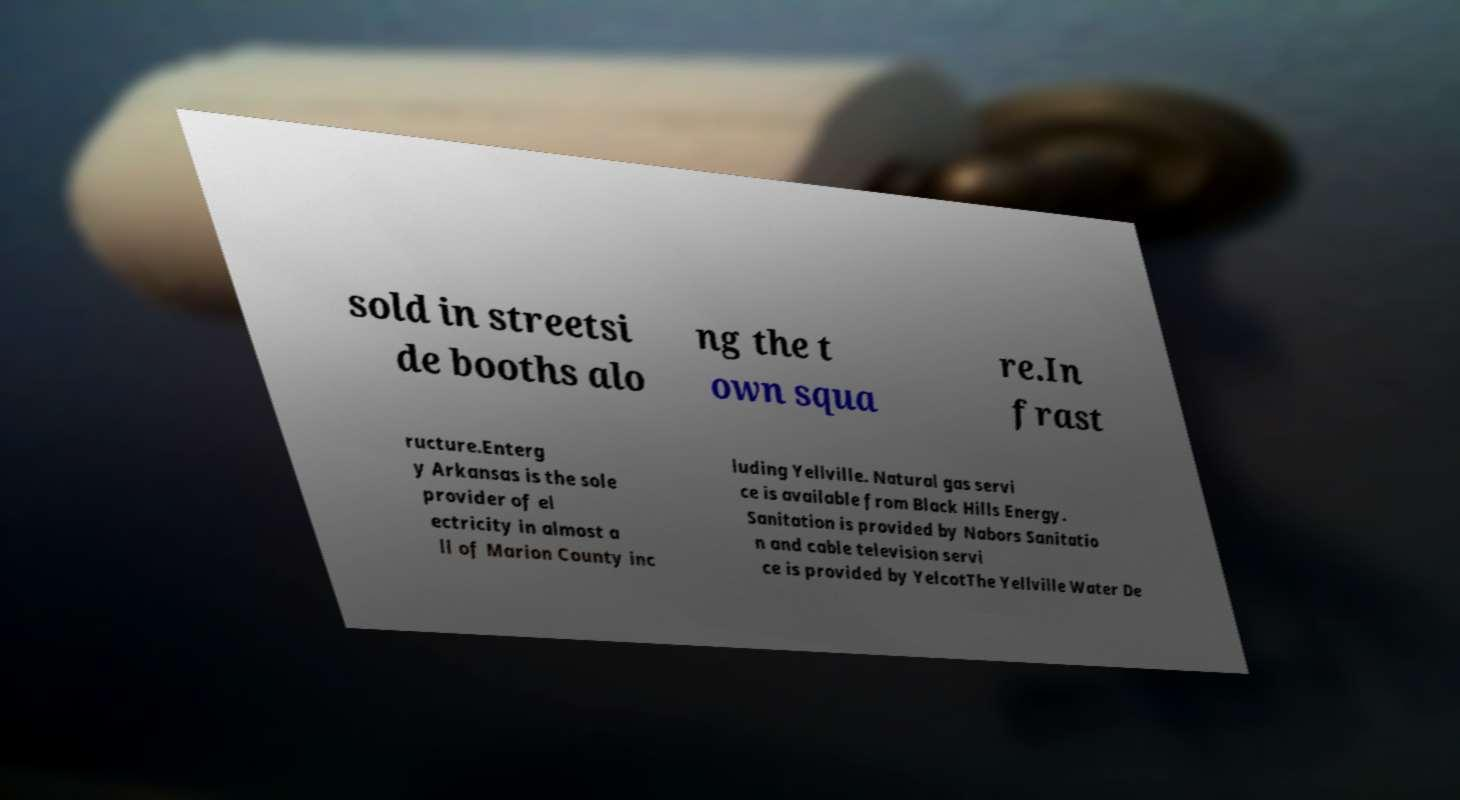Could you assist in decoding the text presented in this image and type it out clearly? sold in streetsi de booths alo ng the t own squa re.In frast ructure.Enterg y Arkansas is the sole provider of el ectricity in almost a ll of Marion County inc luding Yellville. Natural gas servi ce is available from Black Hills Energy. Sanitation is provided by Nabors Sanitatio n and cable television servi ce is provided by YelcotThe Yellville Water De 